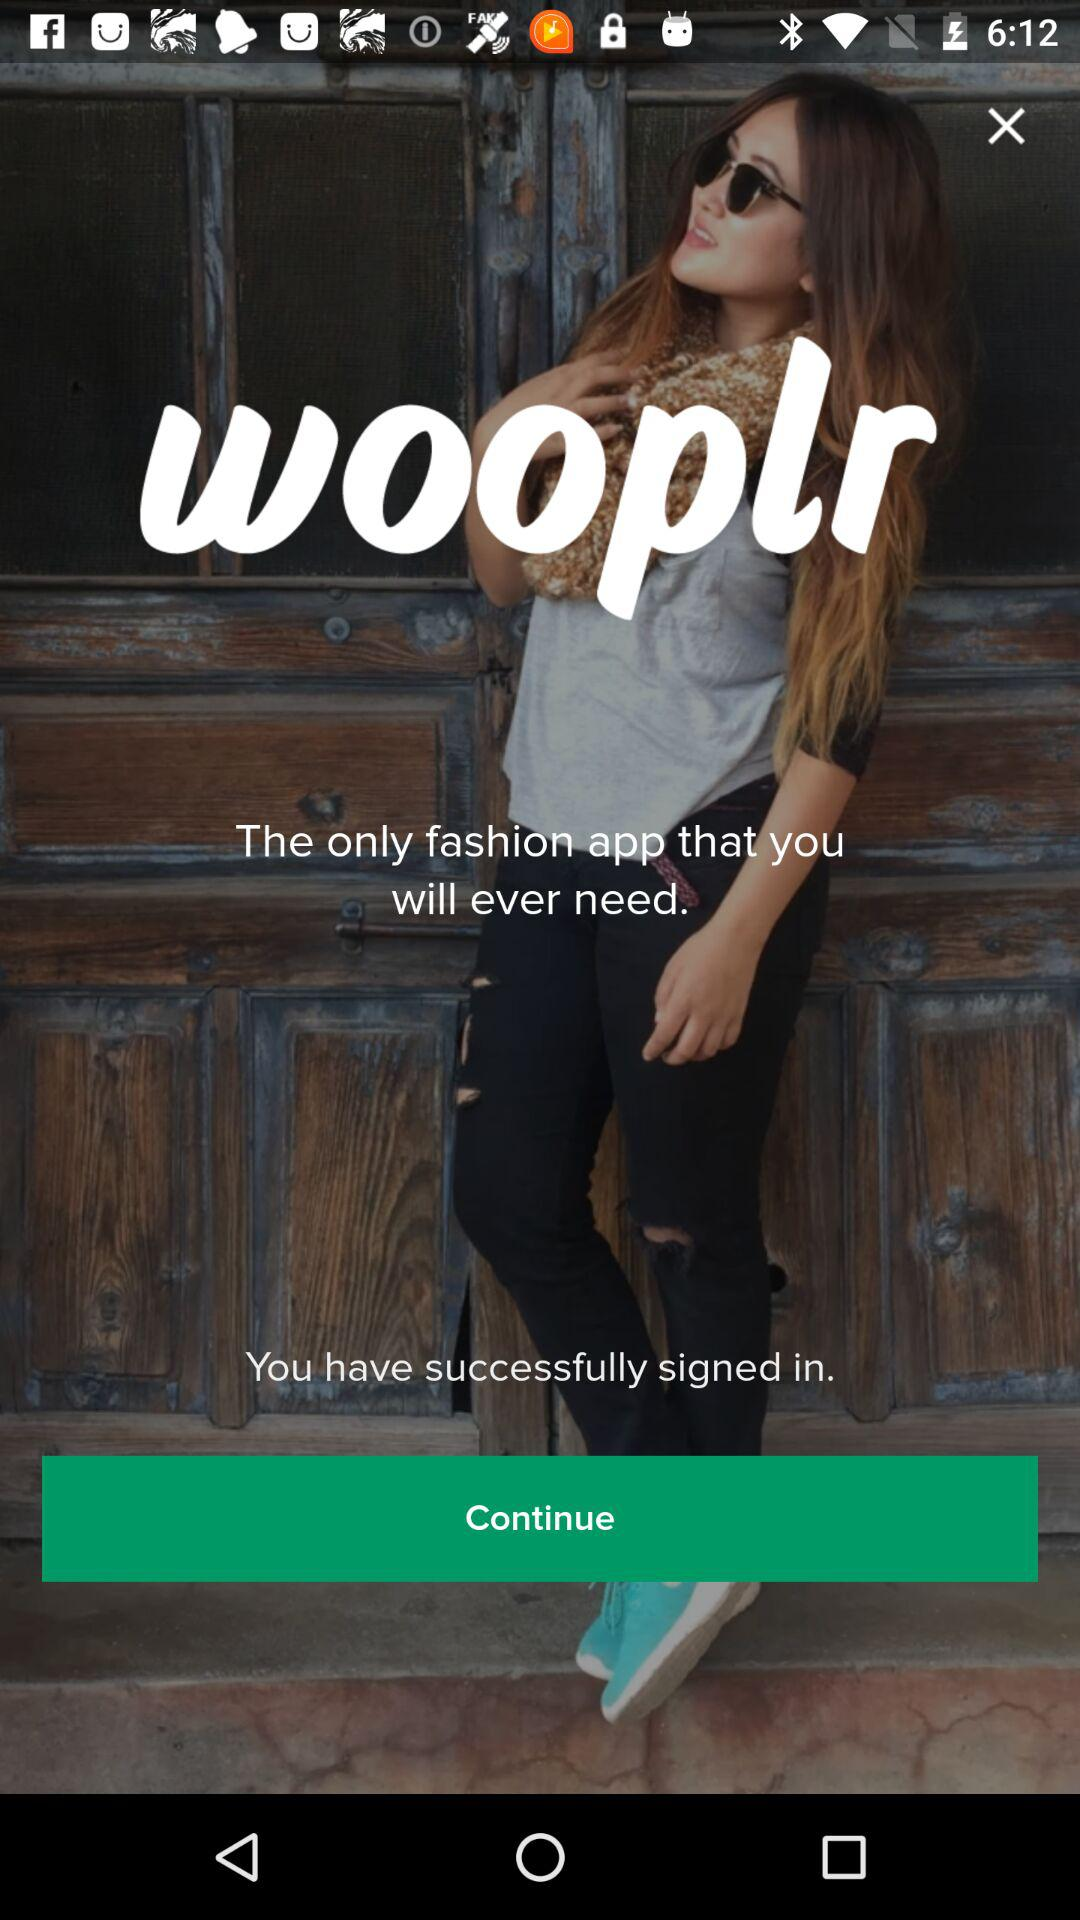What is the application name? The application name is "wooplr". 